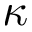<formula> <loc_0><loc_0><loc_500><loc_500>\kappa</formula> 